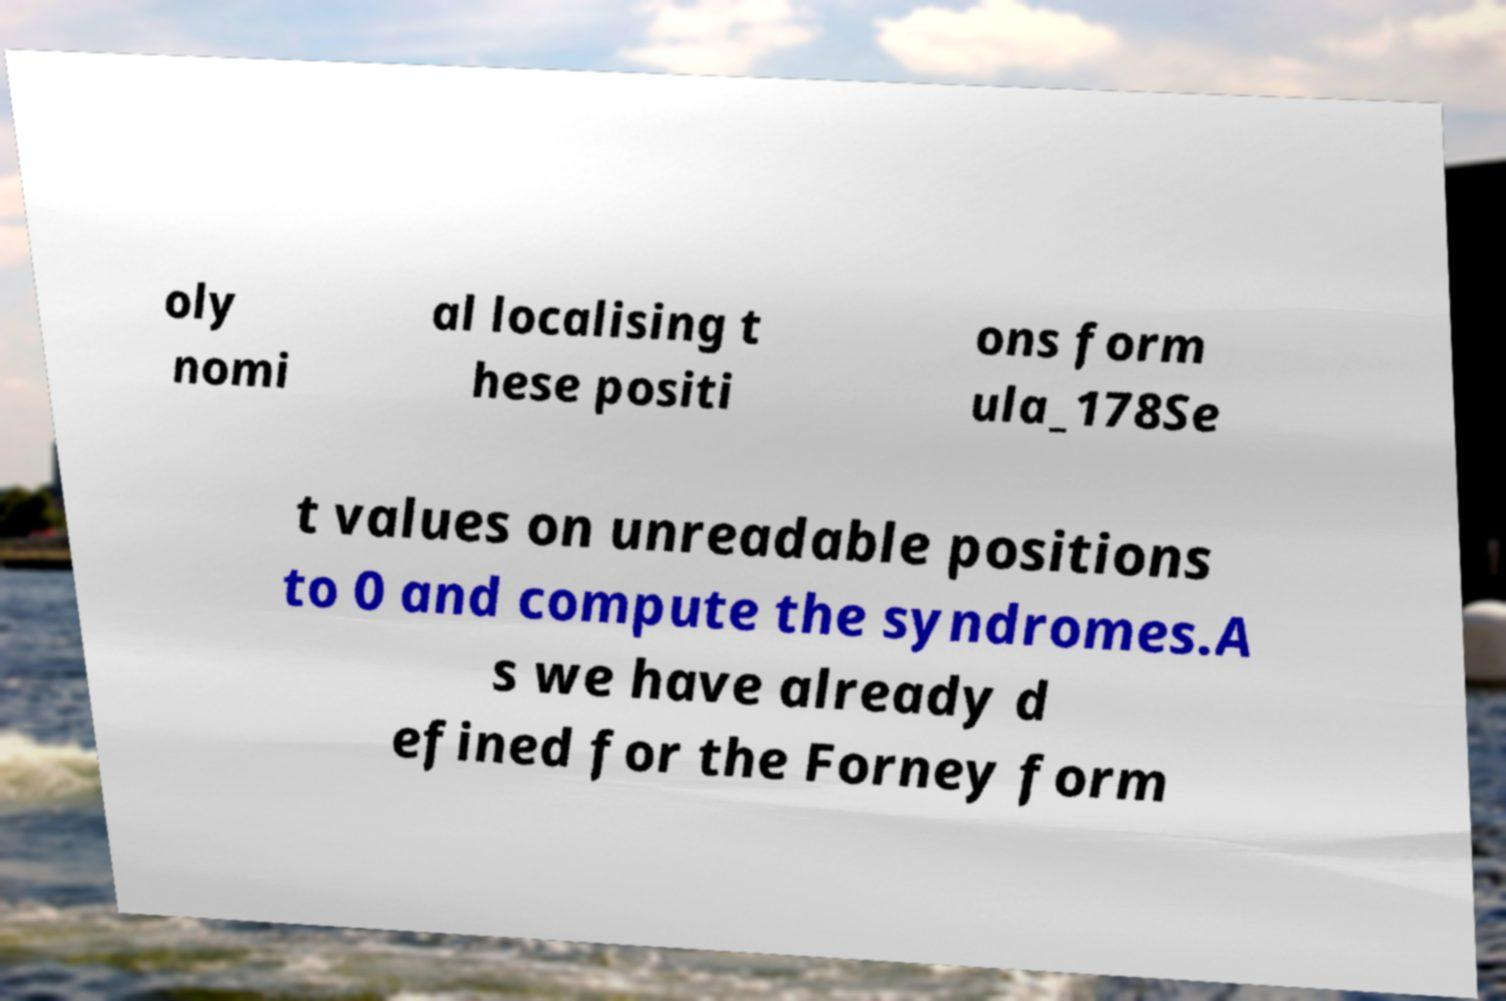For documentation purposes, I need the text within this image transcribed. Could you provide that? oly nomi al localising t hese positi ons form ula_178Se t values on unreadable positions to 0 and compute the syndromes.A s we have already d efined for the Forney form 